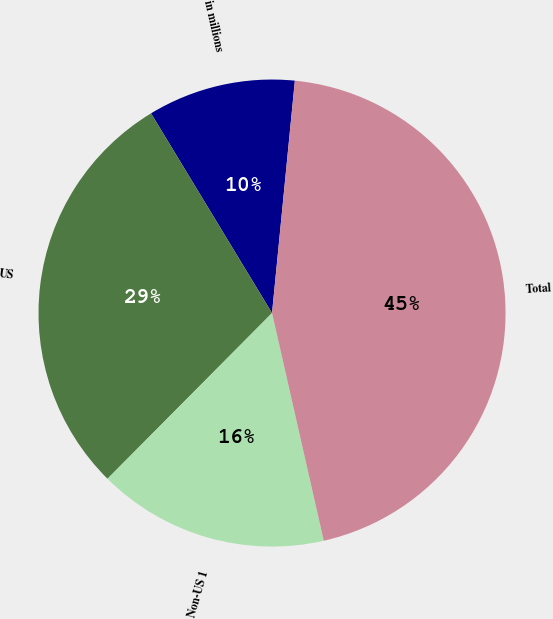Convert chart to OTSL. <chart><loc_0><loc_0><loc_500><loc_500><pie_chart><fcel>in millions<fcel>US<fcel>Non-US 1<fcel>Total<nl><fcel>10.23%<fcel>28.89%<fcel>16.0%<fcel>44.89%<nl></chart> 